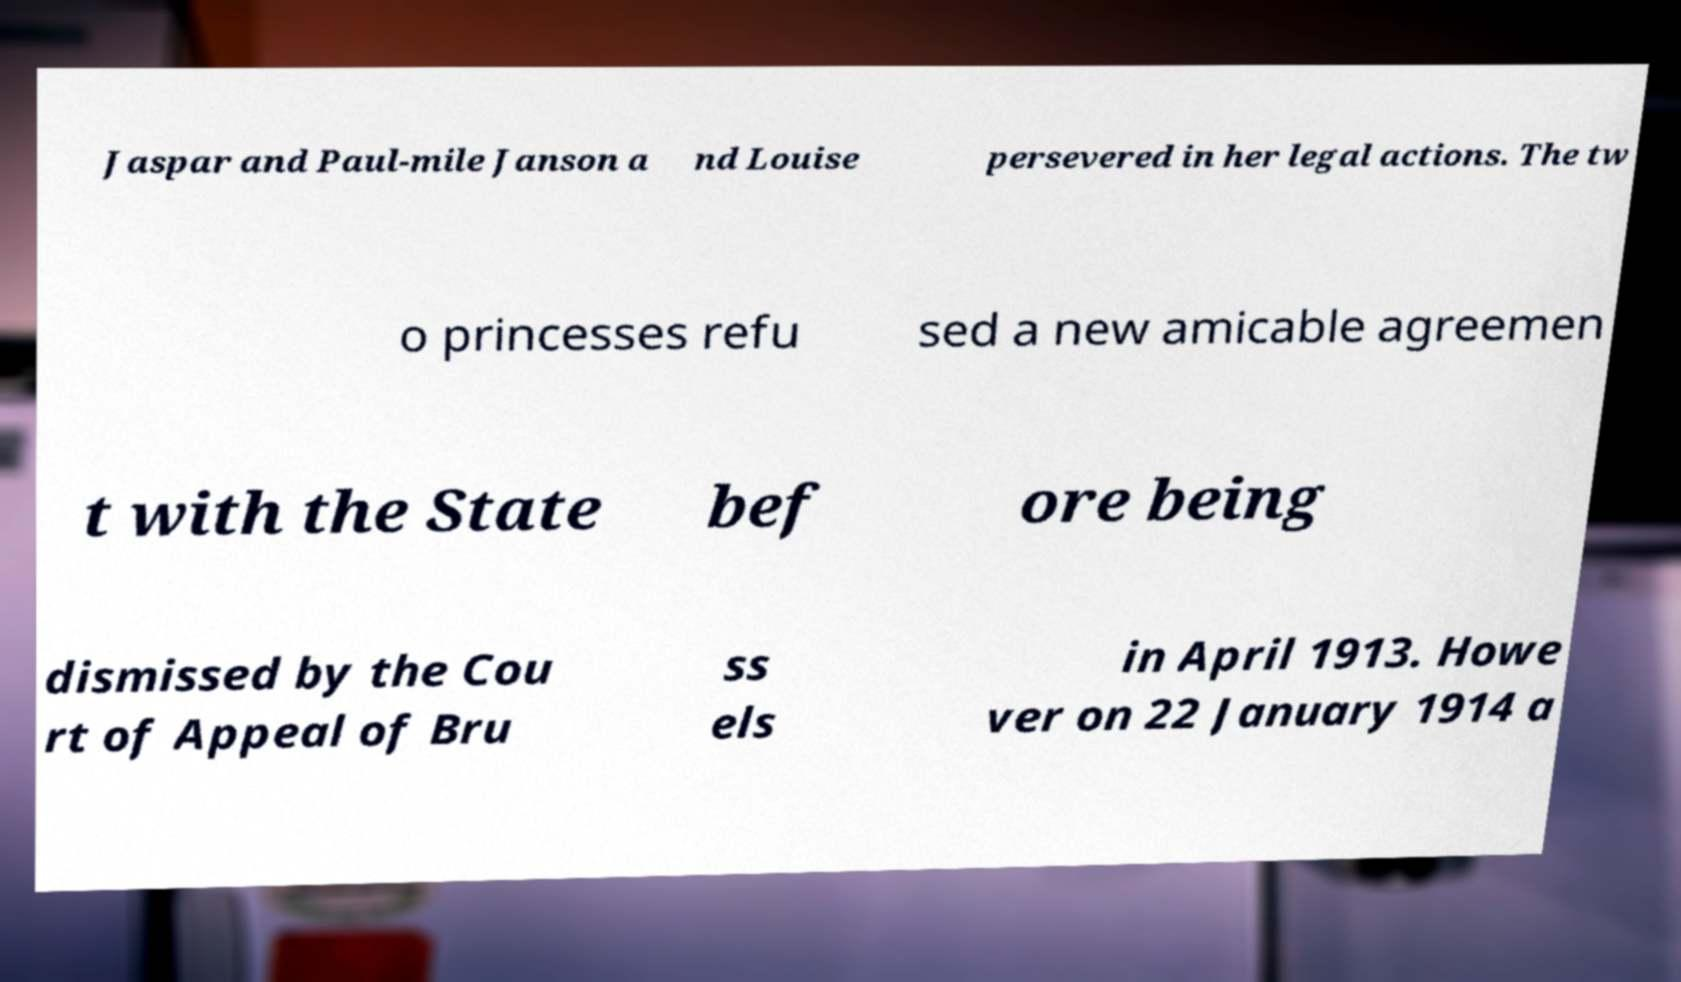For documentation purposes, I need the text within this image transcribed. Could you provide that? Jaspar and Paul-mile Janson a nd Louise persevered in her legal actions. The tw o princesses refu sed a new amicable agreemen t with the State bef ore being dismissed by the Cou rt of Appeal of Bru ss els in April 1913. Howe ver on 22 January 1914 a 